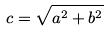Convert formula to latex. <formula><loc_0><loc_0><loc_500><loc_500>c = \sqrt { a ^ { 2 } + b ^ { 2 } }</formula> 